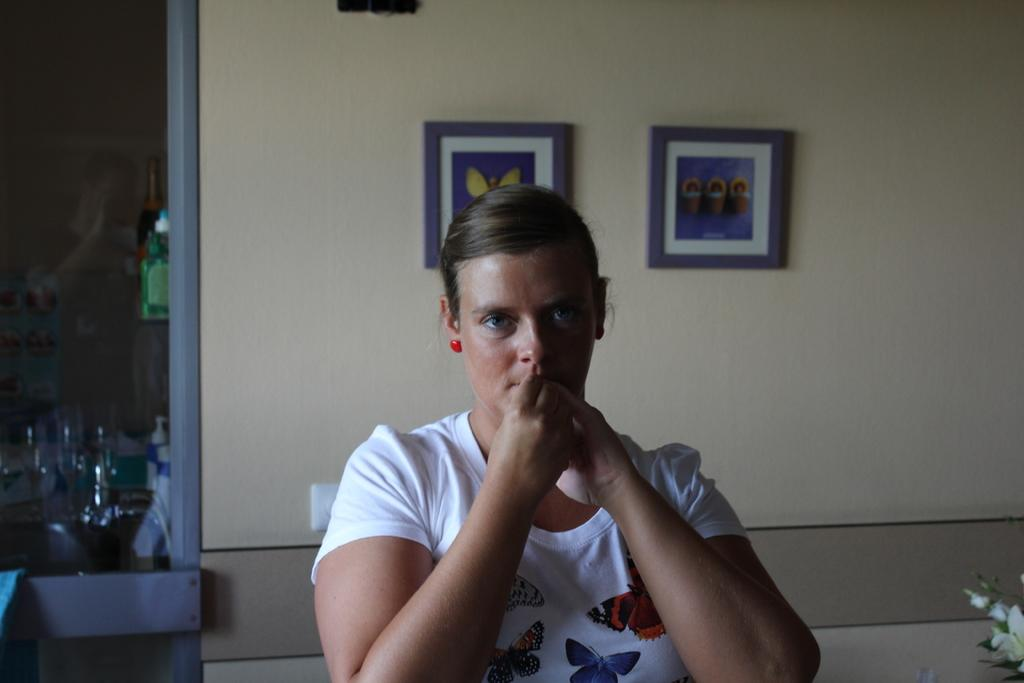Who is the main subject in the image? There is a woman in the center of the image. What can be seen in the background of the image? There are photo frames, glass tumblers, and beverage bottles in the background of the image. What type of surface is visible in the background? There is a wall visible in the background of the image. What type of cup is being used to celebrate the woman's birthday in the image? There is no cup or birthday celebration present in the image. 